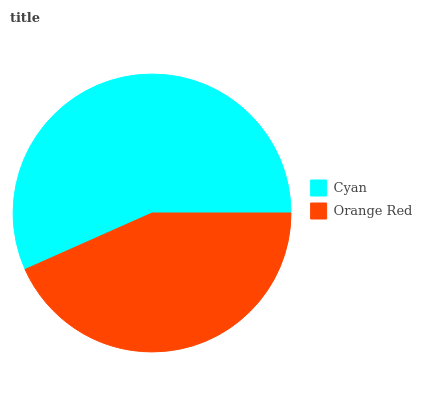Is Orange Red the minimum?
Answer yes or no. Yes. Is Cyan the maximum?
Answer yes or no. Yes. Is Orange Red the maximum?
Answer yes or no. No. Is Cyan greater than Orange Red?
Answer yes or no. Yes. Is Orange Red less than Cyan?
Answer yes or no. Yes. Is Orange Red greater than Cyan?
Answer yes or no. No. Is Cyan less than Orange Red?
Answer yes or no. No. Is Cyan the high median?
Answer yes or no. Yes. Is Orange Red the low median?
Answer yes or no. Yes. Is Orange Red the high median?
Answer yes or no. No. Is Cyan the low median?
Answer yes or no. No. 